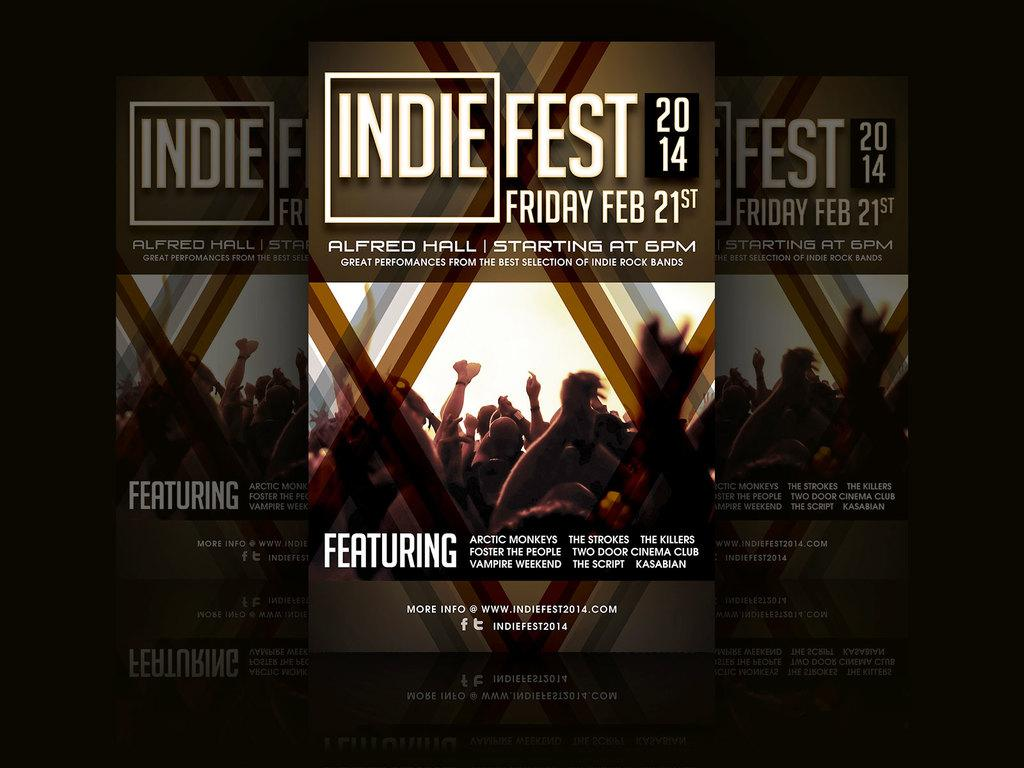<image>
Summarize the visual content of the image. A poster advertises a festival in February 2014. 